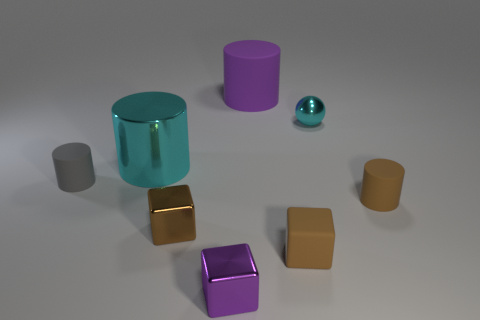Are there any indications of light sources in the image? While there's no explicit light source visible in the image, reflections and shadows on and around the objects suggest a diffuse overhead light illuminating the scene, resulting in soft-edged shadows. 